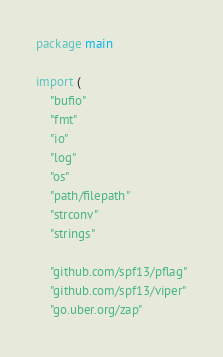Convert code to text. <code><loc_0><loc_0><loc_500><loc_500><_Go_>package main

import (
	"bufio"
	"fmt"
	"io"
	"log"
	"os"
	"path/filepath"
	"strconv"
	"strings"

	"github.com/spf13/pflag"
	"github.com/spf13/viper"
	"go.uber.org/zap"
</code> 